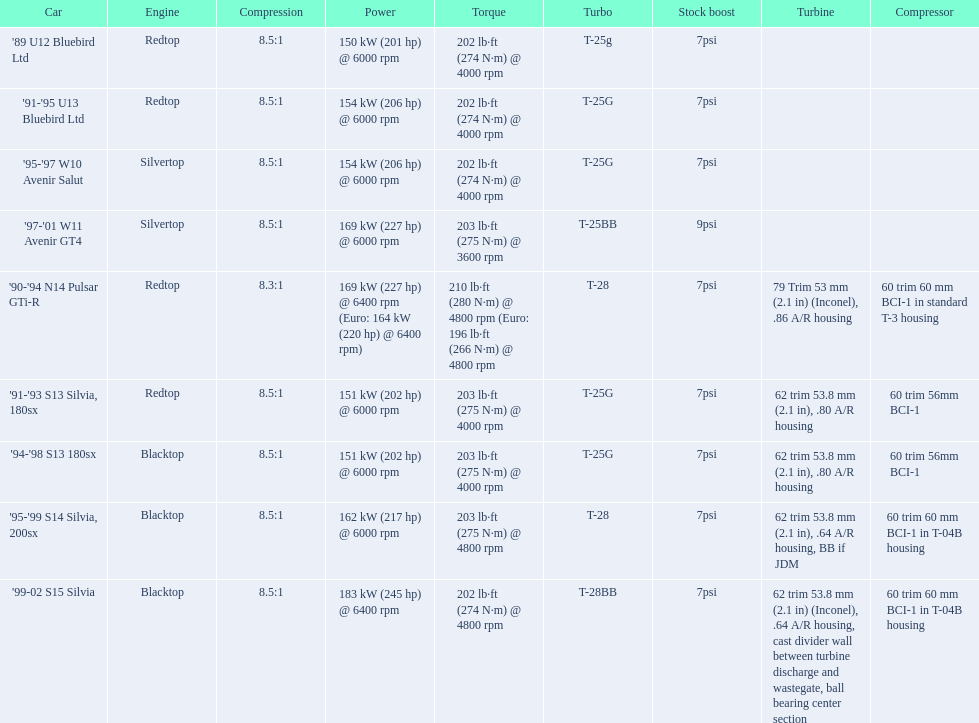Would you mind parsing the complete table? {'header': ['Car', 'Engine', 'Compression', 'Power', 'Torque', 'Turbo', 'Stock boost', 'Turbine', 'Compressor'], 'rows': [["'89 U12 Bluebird Ltd", 'Redtop', '8.5:1', '150\xa0kW (201\xa0hp) @ 6000 rpm', '202\xa0lb·ft (274\xa0N·m) @ 4000 rpm', 'T-25g', '7psi', '', ''], ["'91-'95 U13 Bluebird Ltd", 'Redtop', '8.5:1', '154\xa0kW (206\xa0hp) @ 6000 rpm', '202\xa0lb·ft (274\xa0N·m) @ 4000 rpm', 'T-25G', '7psi', '', ''], ["'95-'97 W10 Avenir Salut", 'Silvertop', '8.5:1', '154\xa0kW (206\xa0hp) @ 6000 rpm', '202\xa0lb·ft (274\xa0N·m) @ 4000 rpm', 'T-25G', '7psi', '', ''], ["'97-'01 W11 Avenir GT4", 'Silvertop', '8.5:1', '169\xa0kW (227\xa0hp) @ 6000 rpm', '203\xa0lb·ft (275\xa0N·m) @ 3600 rpm', 'T-25BB', '9psi', '', ''], ["'90-'94 N14 Pulsar GTi-R", 'Redtop', '8.3:1', '169\xa0kW (227\xa0hp) @ 6400 rpm (Euro: 164\xa0kW (220\xa0hp) @ 6400 rpm)', '210\xa0lb·ft (280\xa0N·m) @ 4800 rpm (Euro: 196\xa0lb·ft (266\xa0N·m) @ 4800 rpm', 'T-28', '7psi', '79 Trim 53\xa0mm (2.1\xa0in) (Inconel), .86 A/R housing', '60 trim 60\xa0mm BCI-1 in standard T-3 housing'], ["'91-'93 S13 Silvia, 180sx", 'Redtop', '8.5:1', '151\xa0kW (202\xa0hp) @ 6000 rpm', '203\xa0lb·ft (275\xa0N·m) @ 4000 rpm', 'T-25G', '7psi', '62 trim 53.8\xa0mm (2.1\xa0in), .80 A/R housing', '60 trim 56mm BCI-1'], ["'94-'98 S13 180sx", 'Blacktop', '8.5:1', '151\xa0kW (202\xa0hp) @ 6000 rpm', '203\xa0lb·ft (275\xa0N·m) @ 4000 rpm', 'T-25G', '7psi', '62 trim 53.8\xa0mm (2.1\xa0in), .80 A/R housing', '60 trim 56mm BCI-1'], ["'95-'99 S14 Silvia, 200sx", 'Blacktop', '8.5:1', '162\xa0kW (217\xa0hp) @ 6000 rpm', '203\xa0lb·ft (275\xa0N·m) @ 4800 rpm', 'T-28', '7psi', '62 trim 53.8\xa0mm (2.1\xa0in), .64 A/R housing, BB if JDM', '60 trim 60\xa0mm BCI-1 in T-04B housing'], ["'99-02 S15 Silvia", 'Blacktop', '8.5:1', '183\xa0kW (245\xa0hp) @ 6400 rpm', '202\xa0lb·ft (274\xa0N·m) @ 4800 rpm', 'T-28BB', '7psi', '62 trim 53.8\xa0mm (2.1\xa0in) (Inconel), .64 A/R housing, cast divider wall between turbine discharge and wastegate, ball bearing center section', '60 trim 60\xa0mm BCI-1 in T-04B housing']]} What are all of the nissan cars? '89 U12 Bluebird Ltd, '91-'95 U13 Bluebird Ltd, '95-'97 W10 Avenir Salut, '97-'01 W11 Avenir GT4, '90-'94 N14 Pulsar GTi-R, '91-'93 S13 Silvia, 180sx, '94-'98 S13 180sx, '95-'99 S14 Silvia, 200sx, '99-02 S15 Silvia. Of these cars, which one is a '90-'94 n14 pulsar gti-r? '90-'94 N14 Pulsar GTi-R. What is the compression of this car? 8.3:1. 